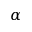Convert formula to latex. <formula><loc_0><loc_0><loc_500><loc_500>\alpha</formula> 